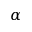Convert formula to latex. <formula><loc_0><loc_0><loc_500><loc_500>\alpha</formula> 